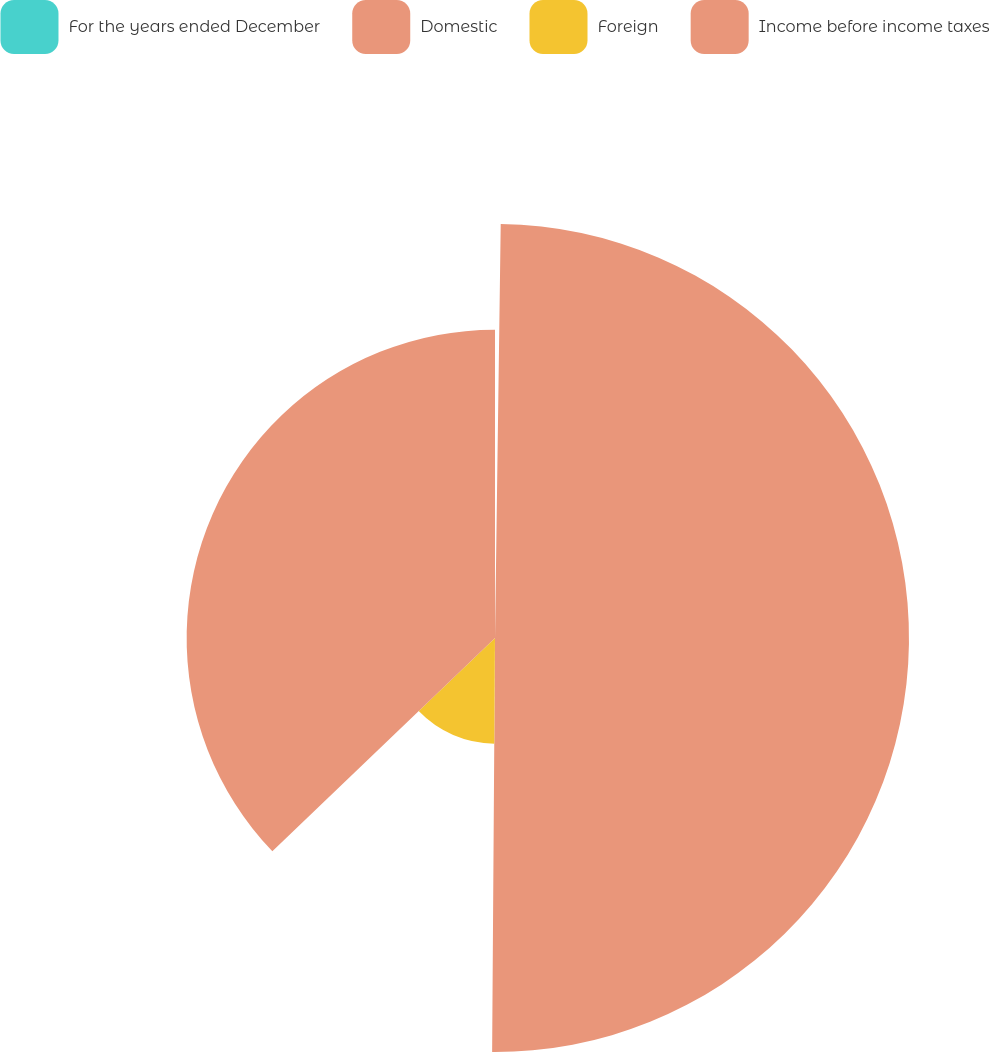Convert chart. <chart><loc_0><loc_0><loc_500><loc_500><pie_chart><fcel>For the years ended December<fcel>Domestic<fcel>Foreign<fcel>Income before income taxes<nl><fcel>0.22%<fcel>49.89%<fcel>12.73%<fcel>37.16%<nl></chart> 